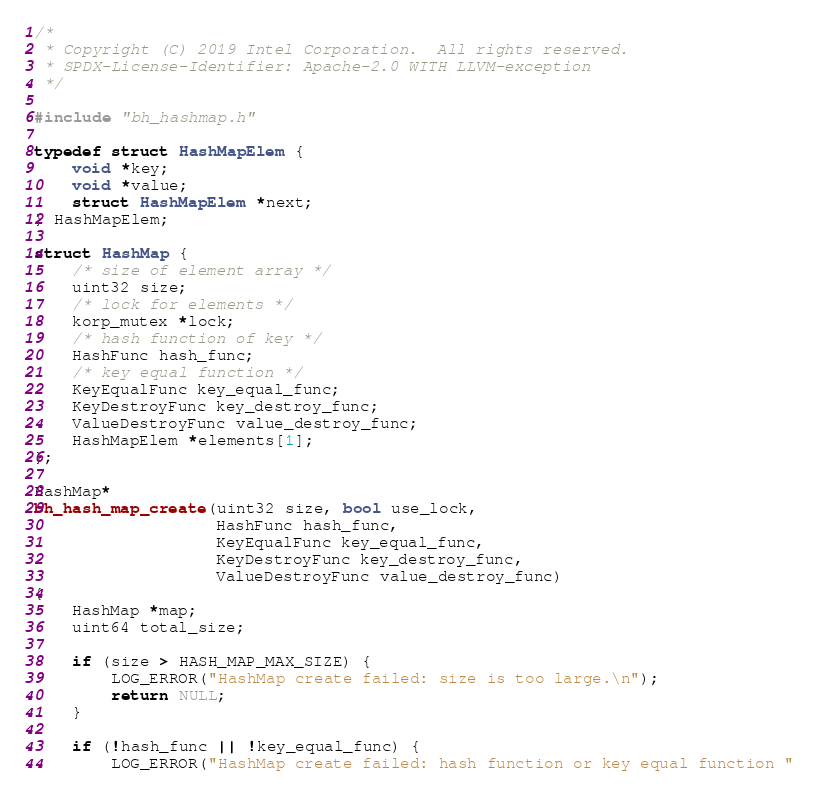<code> <loc_0><loc_0><loc_500><loc_500><_C_>/*
 * Copyright (C) 2019 Intel Corporation.  All rights reserved.
 * SPDX-License-Identifier: Apache-2.0 WITH LLVM-exception
 */

#include "bh_hashmap.h"

typedef struct HashMapElem {
    void *key;
    void *value;
    struct HashMapElem *next;
} HashMapElem;

struct HashMap {
    /* size of element array */
    uint32 size;
    /* lock for elements */
    korp_mutex *lock;
    /* hash function of key */
    HashFunc hash_func;
    /* key equal function */
    KeyEqualFunc key_equal_func;
    KeyDestroyFunc key_destroy_func;
    ValueDestroyFunc value_destroy_func;
    HashMapElem *elements[1];
};

HashMap*
bh_hash_map_create(uint32 size, bool use_lock,
                   HashFunc hash_func,
                   KeyEqualFunc key_equal_func,
                   KeyDestroyFunc key_destroy_func,
                   ValueDestroyFunc value_destroy_func)
{
    HashMap *map;
    uint64 total_size;

    if (size > HASH_MAP_MAX_SIZE) {
        LOG_ERROR("HashMap create failed: size is too large.\n");
        return NULL;
    }

    if (!hash_func || !key_equal_func) {
        LOG_ERROR("HashMap create failed: hash function or key equal function "</code> 